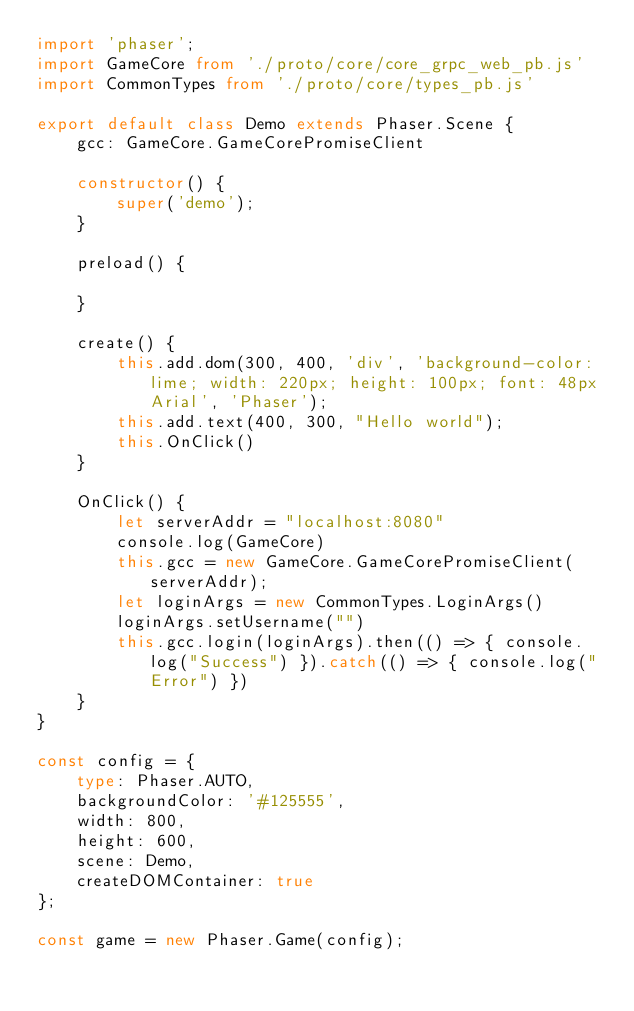<code> <loc_0><loc_0><loc_500><loc_500><_TypeScript_>import 'phaser';
import GameCore from './proto/core/core_grpc_web_pb.js'
import CommonTypes from './proto/core/types_pb.js'

export default class Demo extends Phaser.Scene {
    gcc: GameCore.GameCorePromiseClient

    constructor() {
        super('demo');
    }

    preload() {

    }

    create() {
        this.add.dom(300, 400, 'div', 'background-color: lime; width: 220px; height: 100px; font: 48px Arial', 'Phaser');
        this.add.text(400, 300, "Hello world");
        this.OnClick()
    }

    OnClick() {
        let serverAddr = "localhost:8080"
        console.log(GameCore)
        this.gcc = new GameCore.GameCorePromiseClient(serverAddr);
        let loginArgs = new CommonTypes.LoginArgs()
        loginArgs.setUsername("")
        this.gcc.login(loginArgs).then(() => { console.log("Success") }).catch(() => { console.log("Error") })
    }
}

const config = {
    type: Phaser.AUTO,
    backgroundColor: '#125555',
    width: 800,
    height: 600,
    scene: Demo,
    createDOMContainer: true
};

const game = new Phaser.Game(config);
</code> 